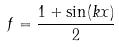Convert formula to latex. <formula><loc_0><loc_0><loc_500><loc_500>f = \frac { 1 + \sin ( k x ) } { 2 }</formula> 